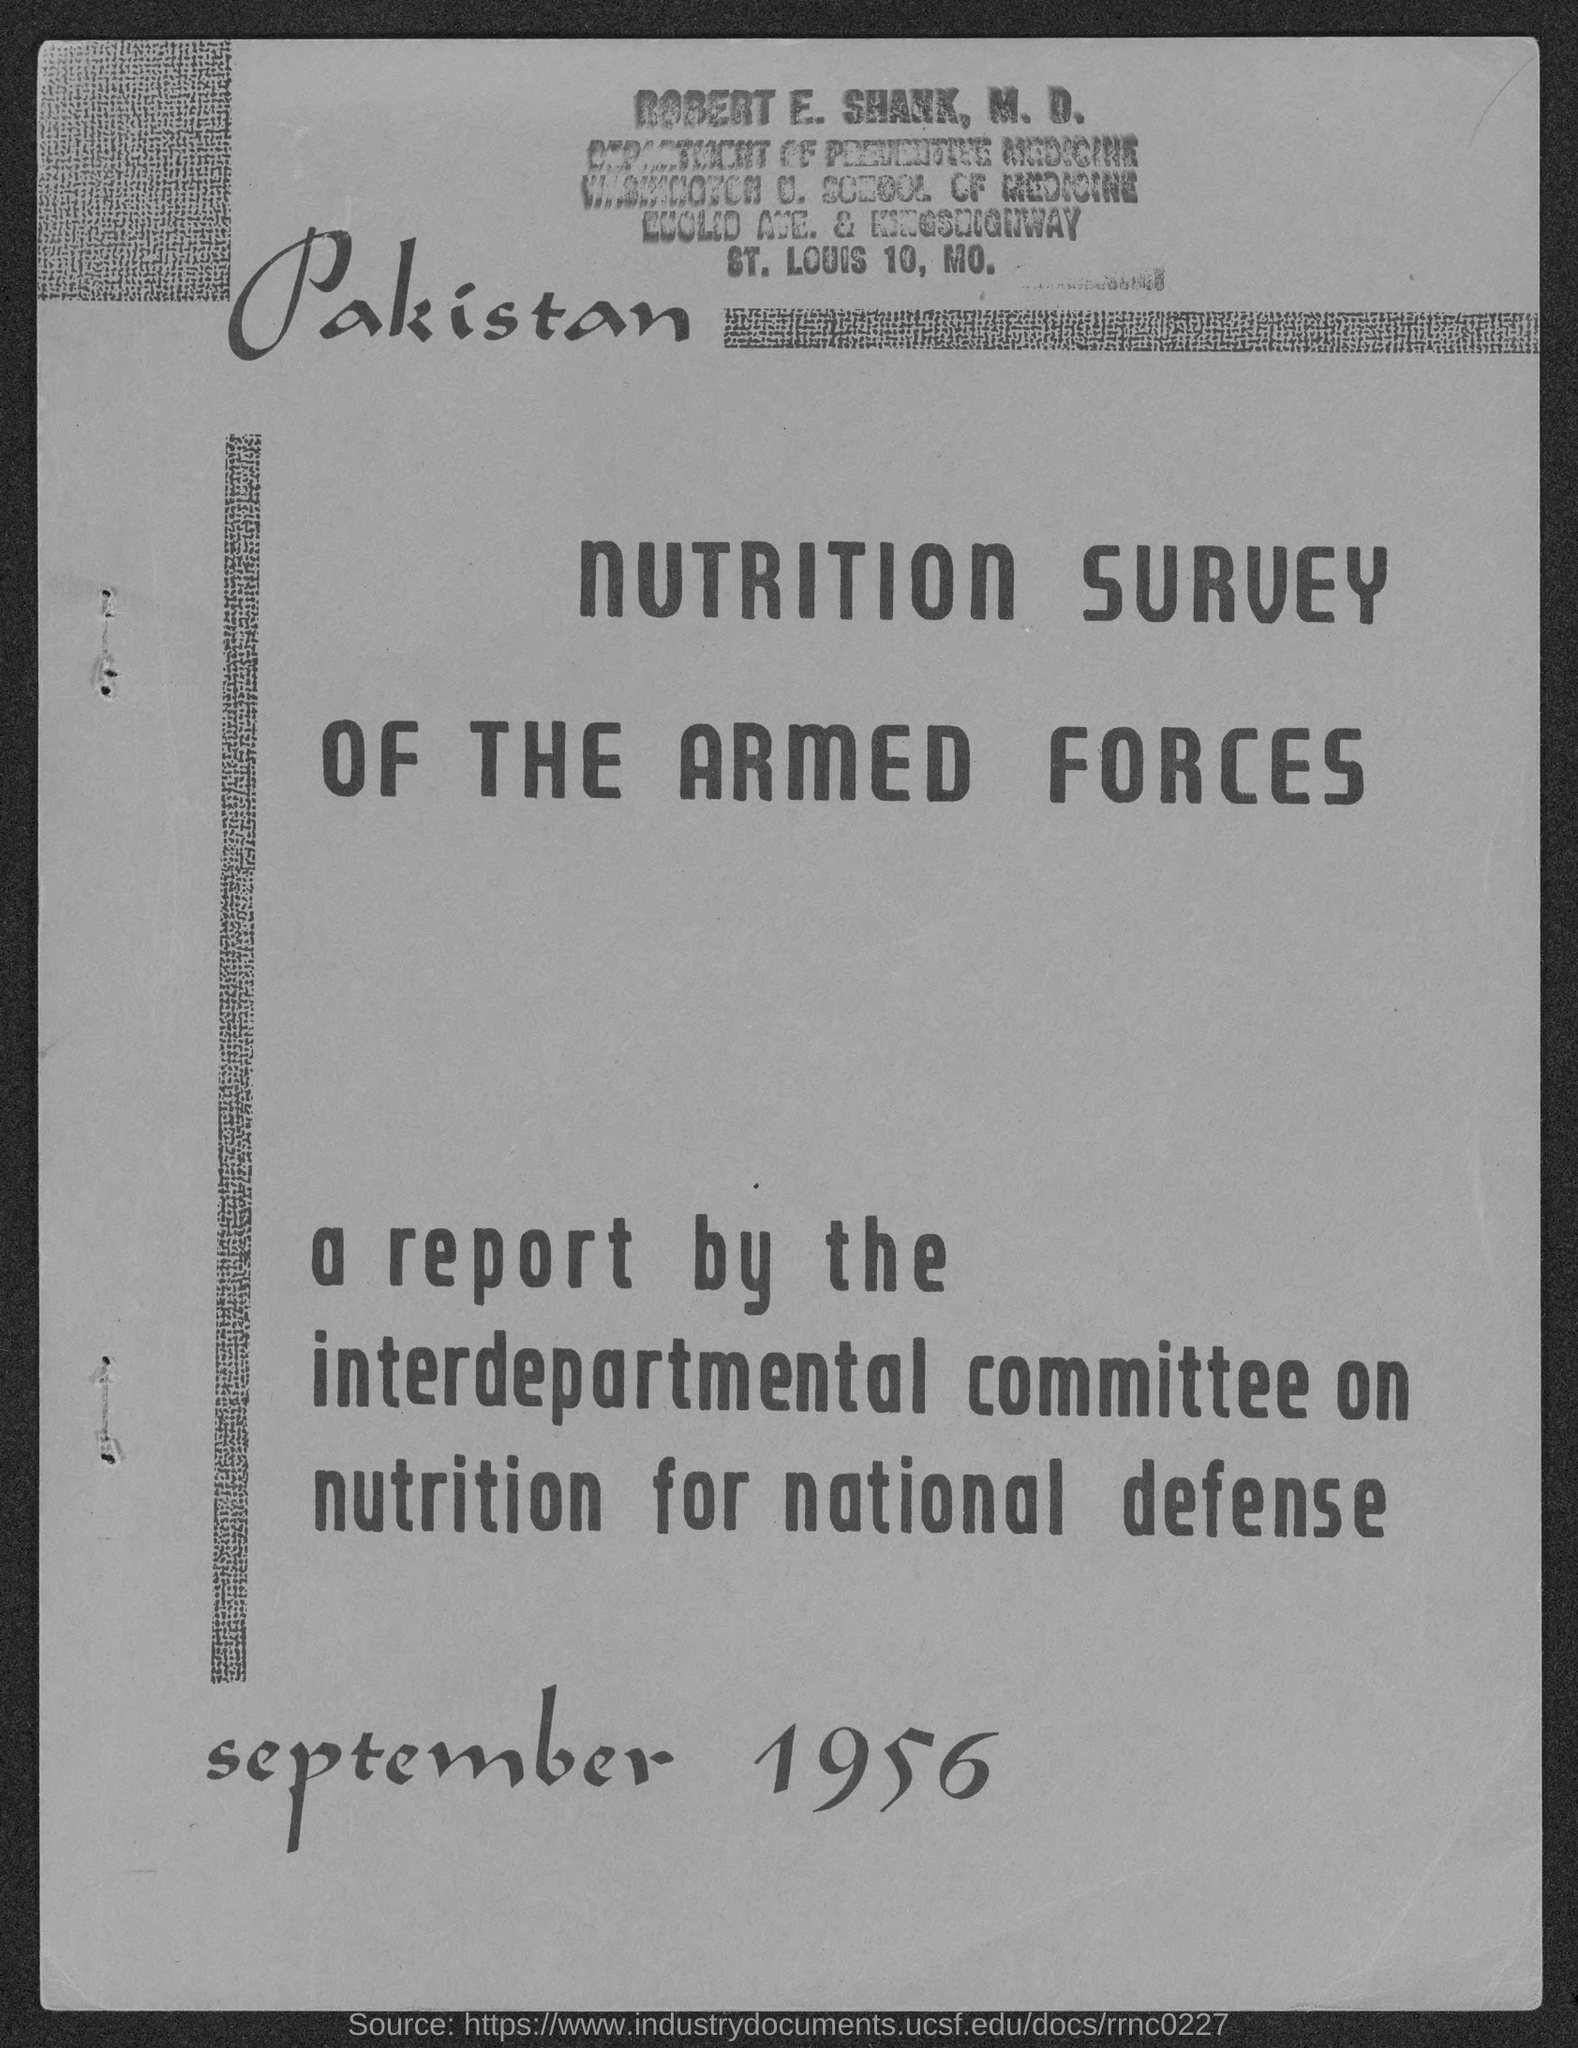List a handful of essential elements in this visual. The document contains a reference to a date in September 1956. 